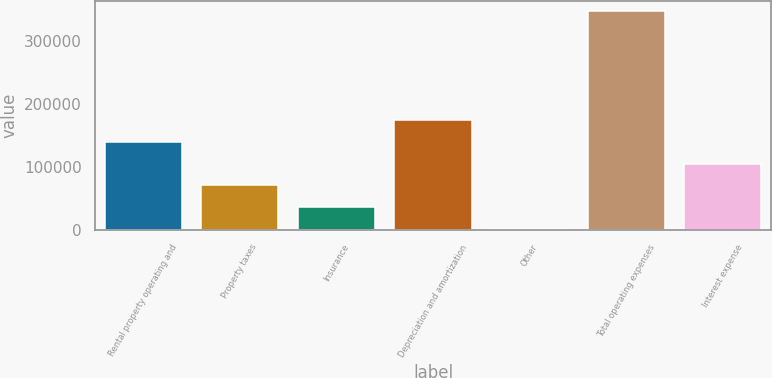Convert chart to OTSL. <chart><loc_0><loc_0><loc_500><loc_500><bar_chart><fcel>Rental property operating and<fcel>Property taxes<fcel>Insurance<fcel>Depreciation and amortization<fcel>Other<fcel>Total operating expenses<fcel>Interest expense<nl><fcel>140029<fcel>70788<fcel>36167.5<fcel>174650<fcel>1547<fcel>347752<fcel>105408<nl></chart> 